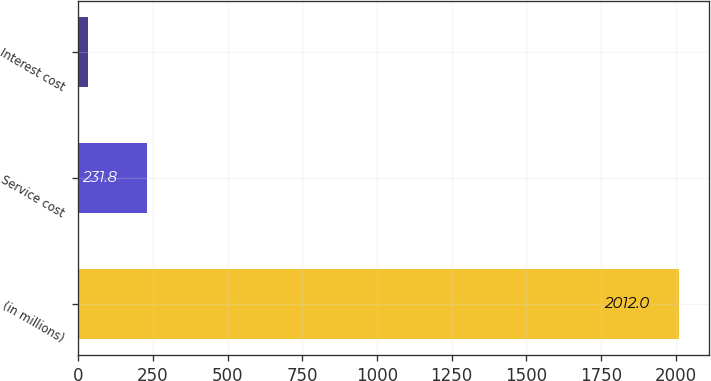Convert chart to OTSL. <chart><loc_0><loc_0><loc_500><loc_500><bar_chart><fcel>(in millions)<fcel>Service cost<fcel>Interest cost<nl><fcel>2012<fcel>231.8<fcel>34<nl></chart> 